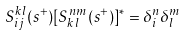<formula> <loc_0><loc_0><loc_500><loc_500>S _ { i j } ^ { k l } ( s ^ { + } ) [ S _ { k l } ^ { n m } ( s ^ { + } ) ] ^ { * } = \delta _ { i } ^ { n } \delta _ { l } ^ { m }</formula> 